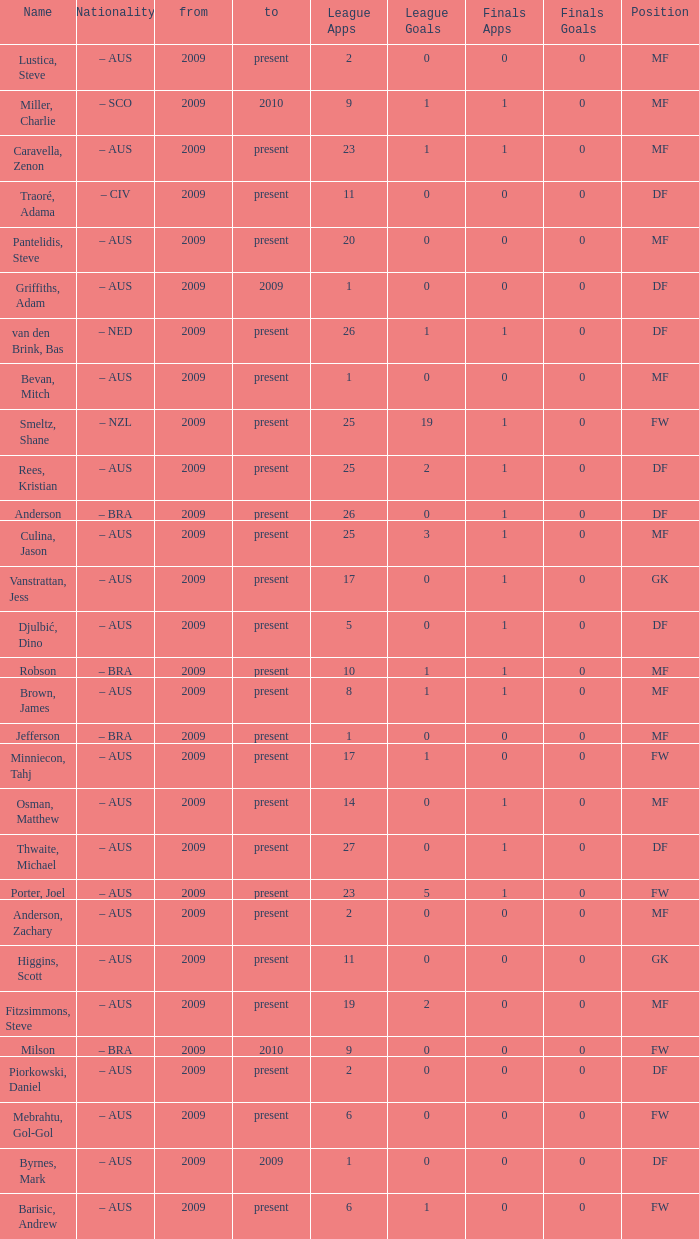Name the to for 19 league apps Present. 